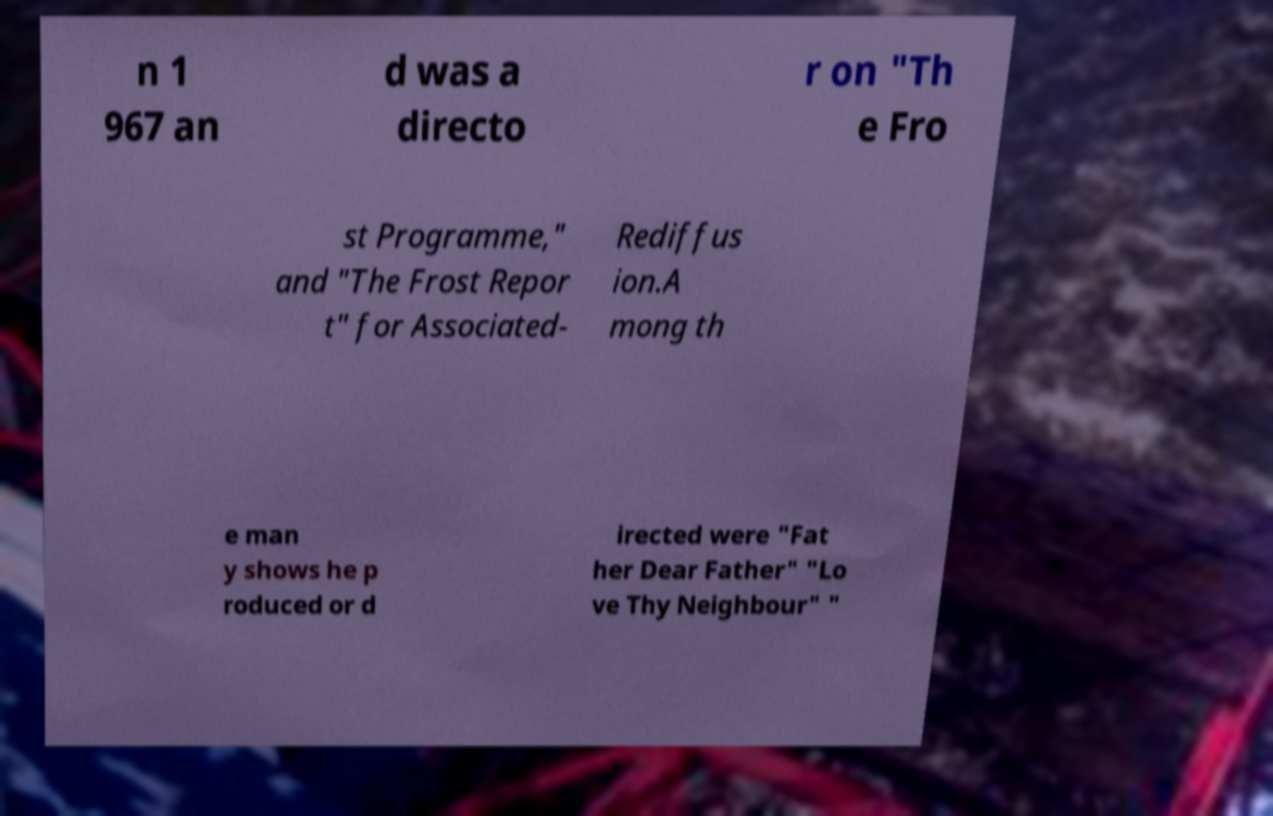I need the written content from this picture converted into text. Can you do that? n 1 967 an d was a directo r on "Th e Fro st Programme," and "The Frost Repor t" for Associated- Rediffus ion.A mong th e man y shows he p roduced or d irected were "Fat her Dear Father" "Lo ve Thy Neighbour" " 